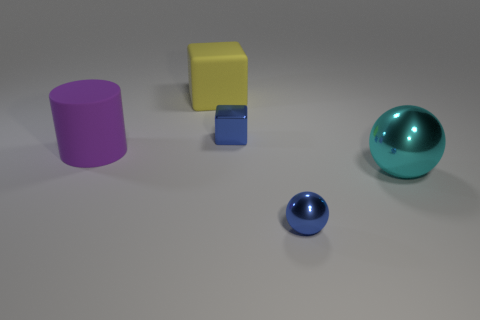Subtract 1 blocks. How many blocks are left? 1 Add 1 tiny cubes. How many objects exist? 6 Subtract all cylinders. How many objects are left? 4 Subtract all gray cylinders. Subtract all blue balls. How many cylinders are left? 1 Subtract all red cylinders. Subtract all matte cylinders. How many objects are left? 4 Add 3 big cyan metal objects. How many big cyan metal objects are left? 4 Add 1 cyan shiny balls. How many cyan shiny balls exist? 2 Subtract 0 brown balls. How many objects are left? 5 